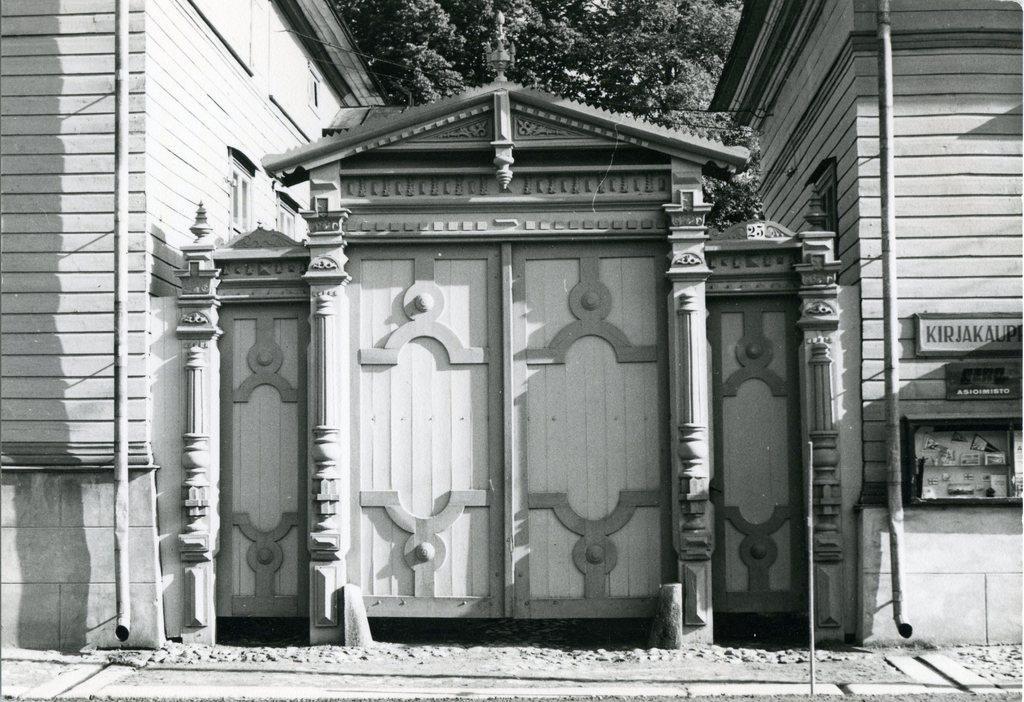Describe this image in one or two sentences. In this picture there is a wooden gate and there are buildings on either sides of it and there are trees in the background. 